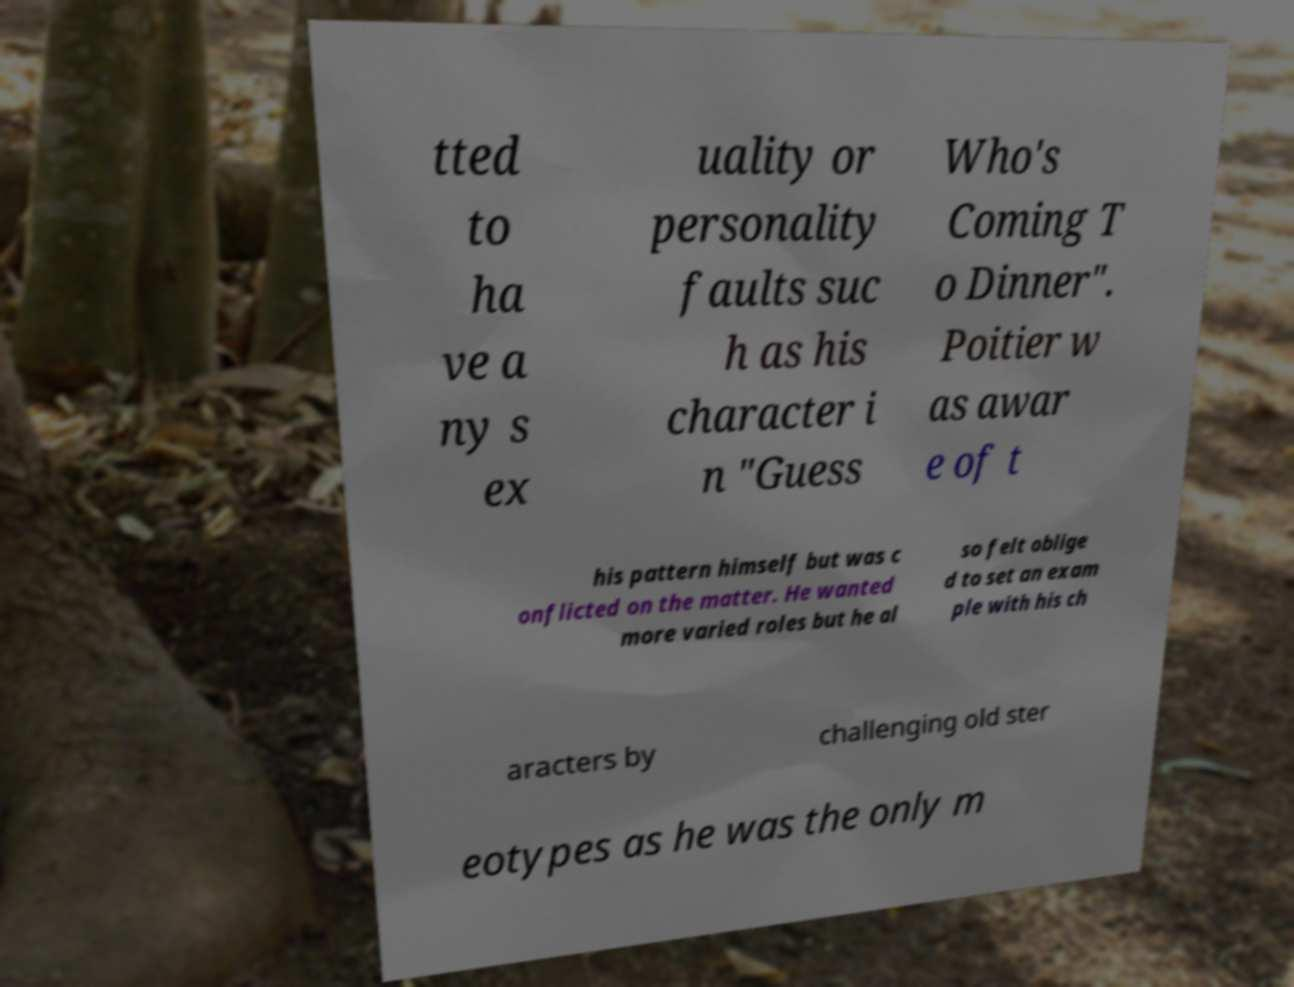There's text embedded in this image that I need extracted. Can you transcribe it verbatim? tted to ha ve a ny s ex uality or personality faults suc h as his character i n "Guess Who's Coming T o Dinner". Poitier w as awar e of t his pattern himself but was c onflicted on the matter. He wanted more varied roles but he al so felt oblige d to set an exam ple with his ch aracters by challenging old ster eotypes as he was the only m 